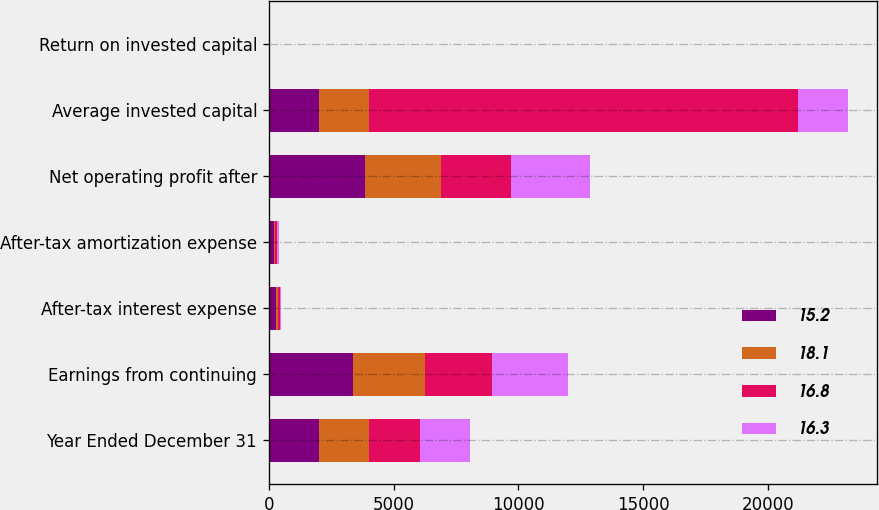Convert chart to OTSL. <chart><loc_0><loc_0><loc_500><loc_500><stacked_bar_chart><ecel><fcel>Year Ended December 31<fcel>Earnings from continuing<fcel>After-tax interest expense<fcel>After-tax amortization expense<fcel>Net operating profit after<fcel>Average invested capital<fcel>Return on invested capital<nl><fcel>15.2<fcel>2018<fcel>3358<fcel>295<fcel>213<fcel>3866<fcel>2015<fcel>15.2<nl><fcel>18.1<fcel>2017<fcel>2912<fcel>76<fcel>51<fcel>3039<fcel>2015<fcel>16.8<nl><fcel>16.8<fcel>2016<fcel>2679<fcel>64<fcel>57<fcel>2800<fcel>17168<fcel>16.3<nl><fcel>16.3<fcel>2015<fcel>3036<fcel>64<fcel>75<fcel>3175<fcel>2015<fcel>18.1<nl></chart> 